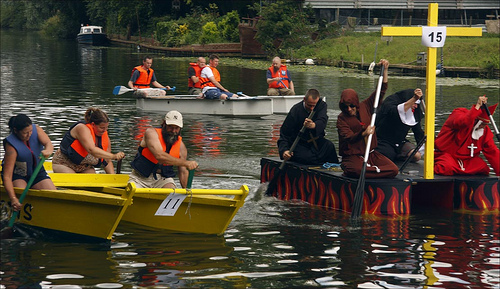<image>
Is there a flames in the water? Yes. The flames is contained within or inside the water, showing a containment relationship. 